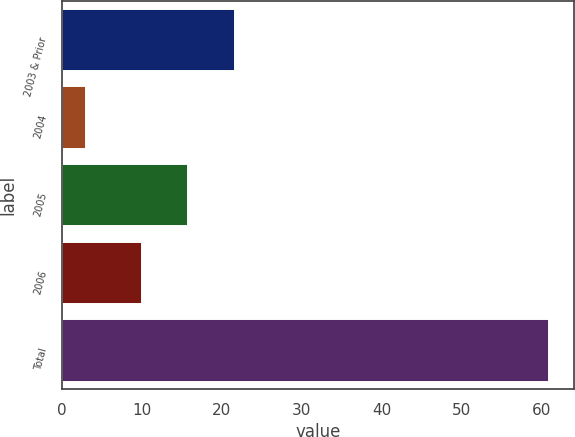Convert chart. <chart><loc_0><loc_0><loc_500><loc_500><bar_chart><fcel>2003 & Prior<fcel>2004<fcel>2005<fcel>2006<fcel>Total<nl><fcel>21.6<fcel>3<fcel>15.8<fcel>10<fcel>61<nl></chart> 